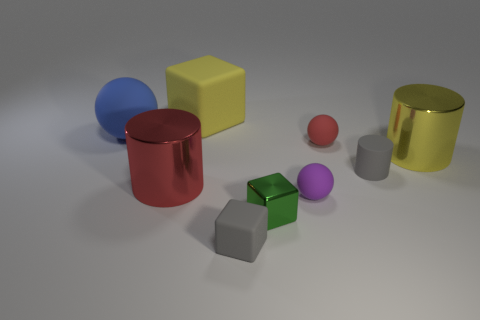What number of other things are there of the same size as the red rubber object?
Your response must be concise. 4. There is a big blue thing; what number of big matte objects are behind it?
Give a very brief answer. 1. The shiny cube is what size?
Offer a terse response. Small. Does the small object behind the large yellow metal thing have the same material as the small sphere that is in front of the yellow metallic cylinder?
Your answer should be compact. Yes. Are there any big cylinders of the same color as the big cube?
Keep it short and to the point. Yes. There is a rubber cube that is the same size as the purple thing; what is its color?
Make the answer very short. Gray. There is a metal cylinder that is to the right of the red metallic thing; does it have the same color as the tiny cylinder?
Offer a very short reply. No. Are there any tiny purple spheres that have the same material as the big yellow cylinder?
Your answer should be very brief. No. There is a big thing that is the same color as the large matte block; what shape is it?
Keep it short and to the point. Cylinder. Are there fewer red objects that are in front of the tiny metallic object than big red cylinders?
Your answer should be compact. Yes. 